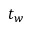Convert formula to latex. <formula><loc_0><loc_0><loc_500><loc_500>t _ { w }</formula> 